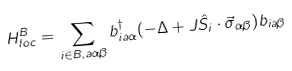Convert formula to latex. <formula><loc_0><loc_0><loc_500><loc_500>H _ { l o c } ^ { B } = \sum _ { i \in B , a \alpha \beta } b _ { i a \alpha } ^ { \dagger } ( - \Delta + J \hat { S } _ { i } \cdot \vec { \sigma } _ { \alpha \beta } ) b _ { i a \beta }</formula> 